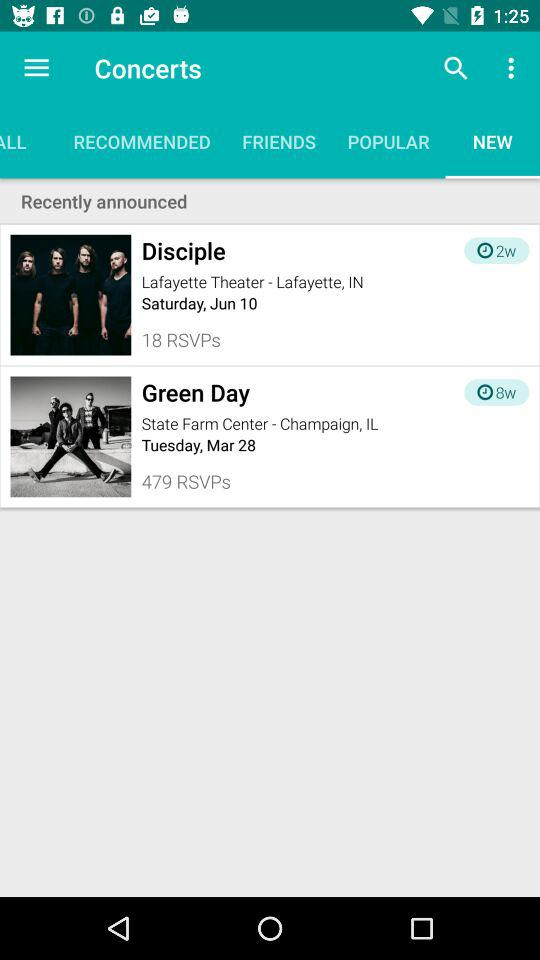How many weeks ago was the "Disciple" concert announced? The "Disciple" concert was announced 2 weeks ago. 